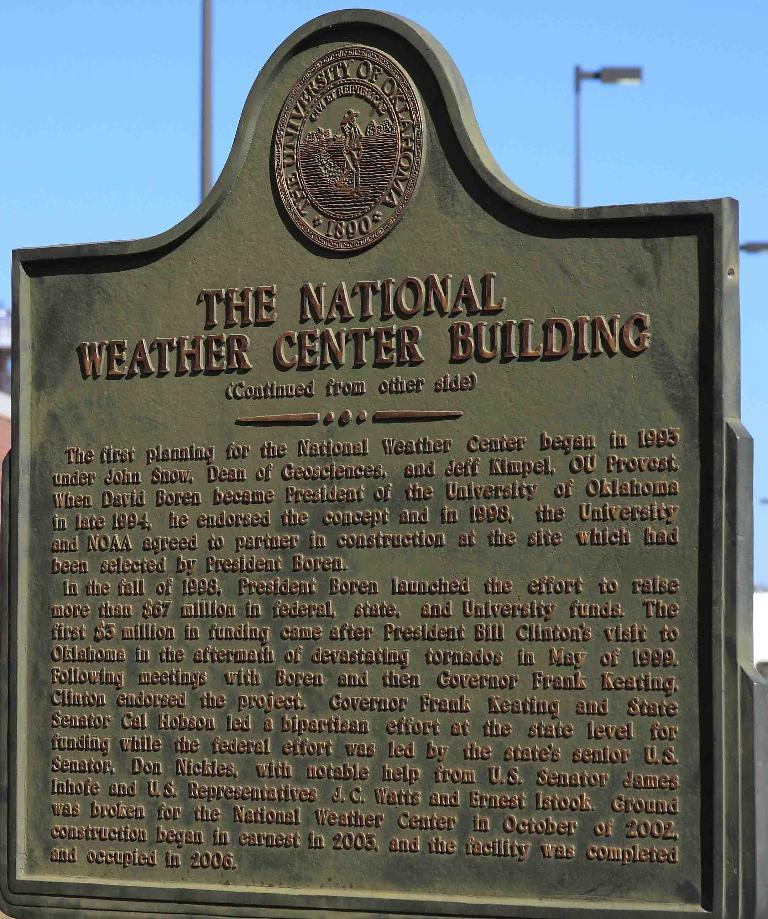<image>
Write a terse but informative summary of the picture. A commemorative landmark marker for the National Weather Center Building. 